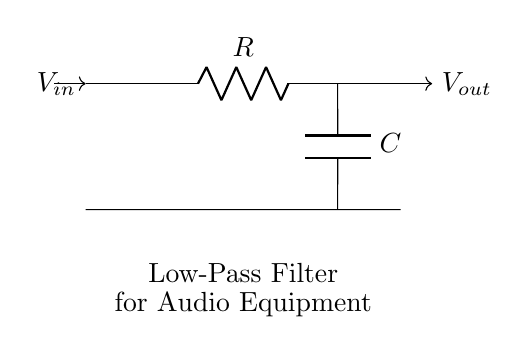What is the type of this circuit? The diagram represents a low-pass filter circuit, which is designed to allow low-frequency signals to pass while attenuating high-frequency signals. This is indicated by the labeling in the diagram.
Answer: low-pass filter What components are in this circuit? The circuit contains a resistor and a capacitor, as specified by the labels R and C in the diagram. These components are essential for the functionality of the filter.
Answer: resistor and capacitor What is the primary function of the low-pass filter? The primary function is to reduce high-frequency noise in audio equipment, allowing only low-frequency signals to pass through effectively. This is inferred from the circuit's design and purpose.
Answer: reduce high-frequency noise How many terminals does the capacitor have? The capacitor typically has two terminals: one connected to the resistor and the other to the ground. This is standard for capacitors in circuit designs.
Answer: two What happens to signals above the cutoff frequency? Signals above the cutoff frequency are attenuated or diminished in amplitude, meaning they get weaker and are less effective in passing through the circuit. This is the fundamental behavior of a low-pass filter.
Answer: attenuated What is the output voltage relation to the input voltage? The output voltage will be lower than the input voltage, particularly for high-frequency signals due to the filtering effect of the circuit. This relation is inherent in the functioning of a low-pass filter.
Answer: lower 